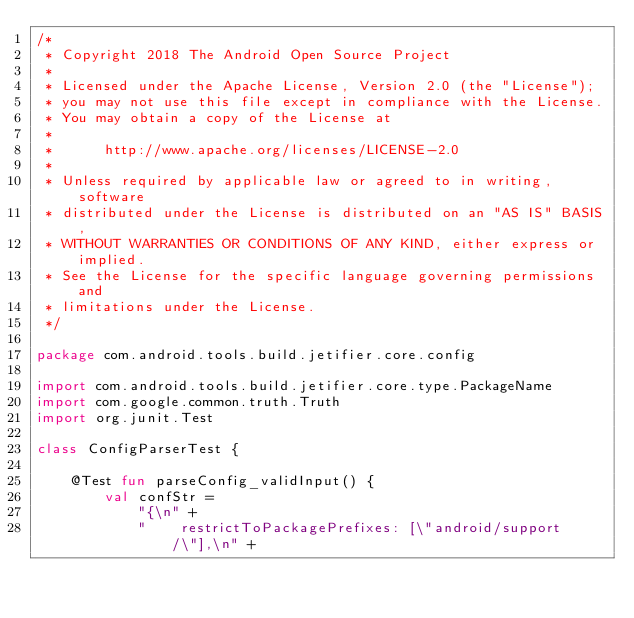Convert code to text. <code><loc_0><loc_0><loc_500><loc_500><_Kotlin_>/*
 * Copyright 2018 The Android Open Source Project
 *
 * Licensed under the Apache License, Version 2.0 (the "License");
 * you may not use this file except in compliance with the License.
 * You may obtain a copy of the License at
 *
 *      http://www.apache.org/licenses/LICENSE-2.0
 *
 * Unless required by applicable law or agreed to in writing, software
 * distributed under the License is distributed on an "AS IS" BASIS,
 * WITHOUT WARRANTIES OR CONDITIONS OF ANY KIND, either express or implied.
 * See the License for the specific language governing permissions and
 * limitations under the License.
 */

package com.android.tools.build.jetifier.core.config

import com.android.tools.build.jetifier.core.type.PackageName
import com.google.common.truth.Truth
import org.junit.Test

class ConfigParserTest {

    @Test fun parseConfig_validInput() {
        val confStr =
            "{\n" +
            "    restrictToPackagePrefixes: [\"android/support/\"],\n" +</code> 